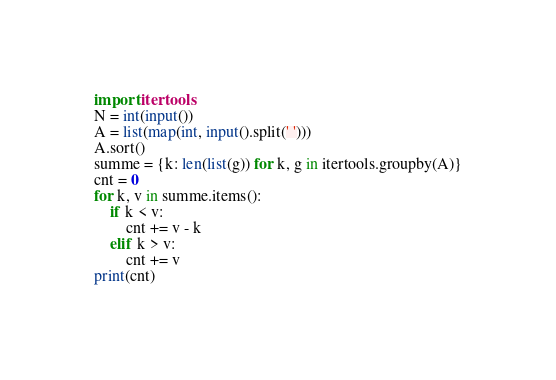<code> <loc_0><loc_0><loc_500><loc_500><_Python_>import itertools
N = int(input())
A = list(map(int, input().split(' ')))
A.sort()
summe = {k: len(list(g)) for k, g in itertools.groupby(A)}
cnt = 0
for k, v in summe.items():
    if k < v:
        cnt += v - k
    elif k > v:
        cnt += v
print(cnt)</code> 